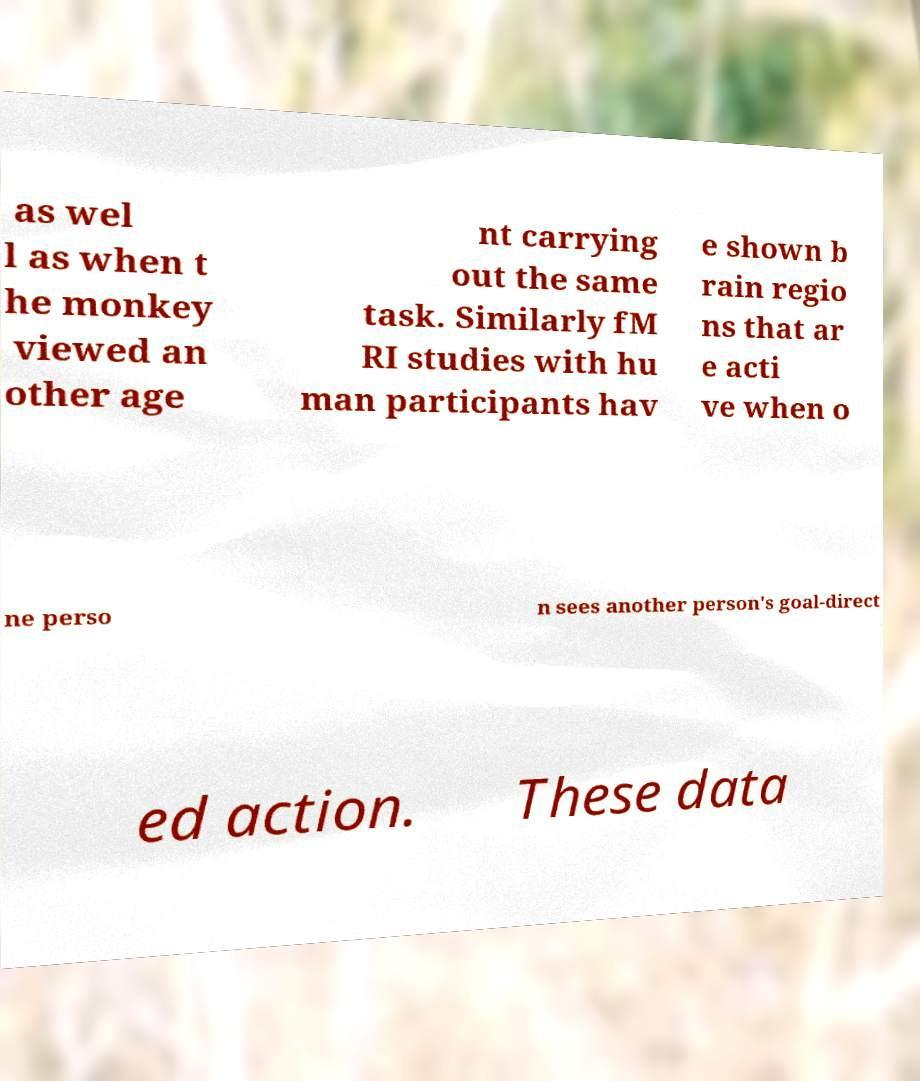What messages or text are displayed in this image? I need them in a readable, typed format. as wel l as when t he monkey viewed an other age nt carrying out the same task. Similarly fM RI studies with hu man participants hav e shown b rain regio ns that ar e acti ve when o ne perso n sees another person's goal-direct ed action. These data 